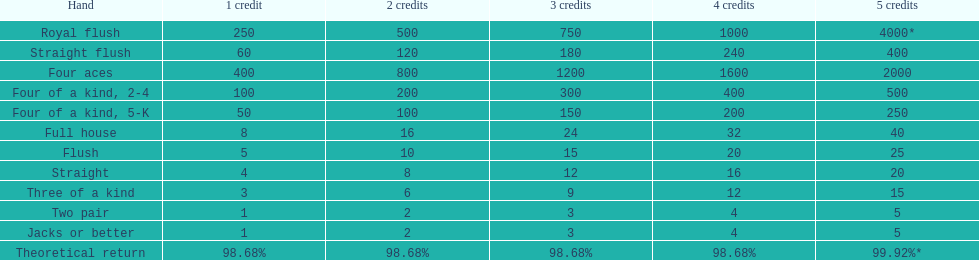At the greatest, what could a person gain for owning a full house? 40. 